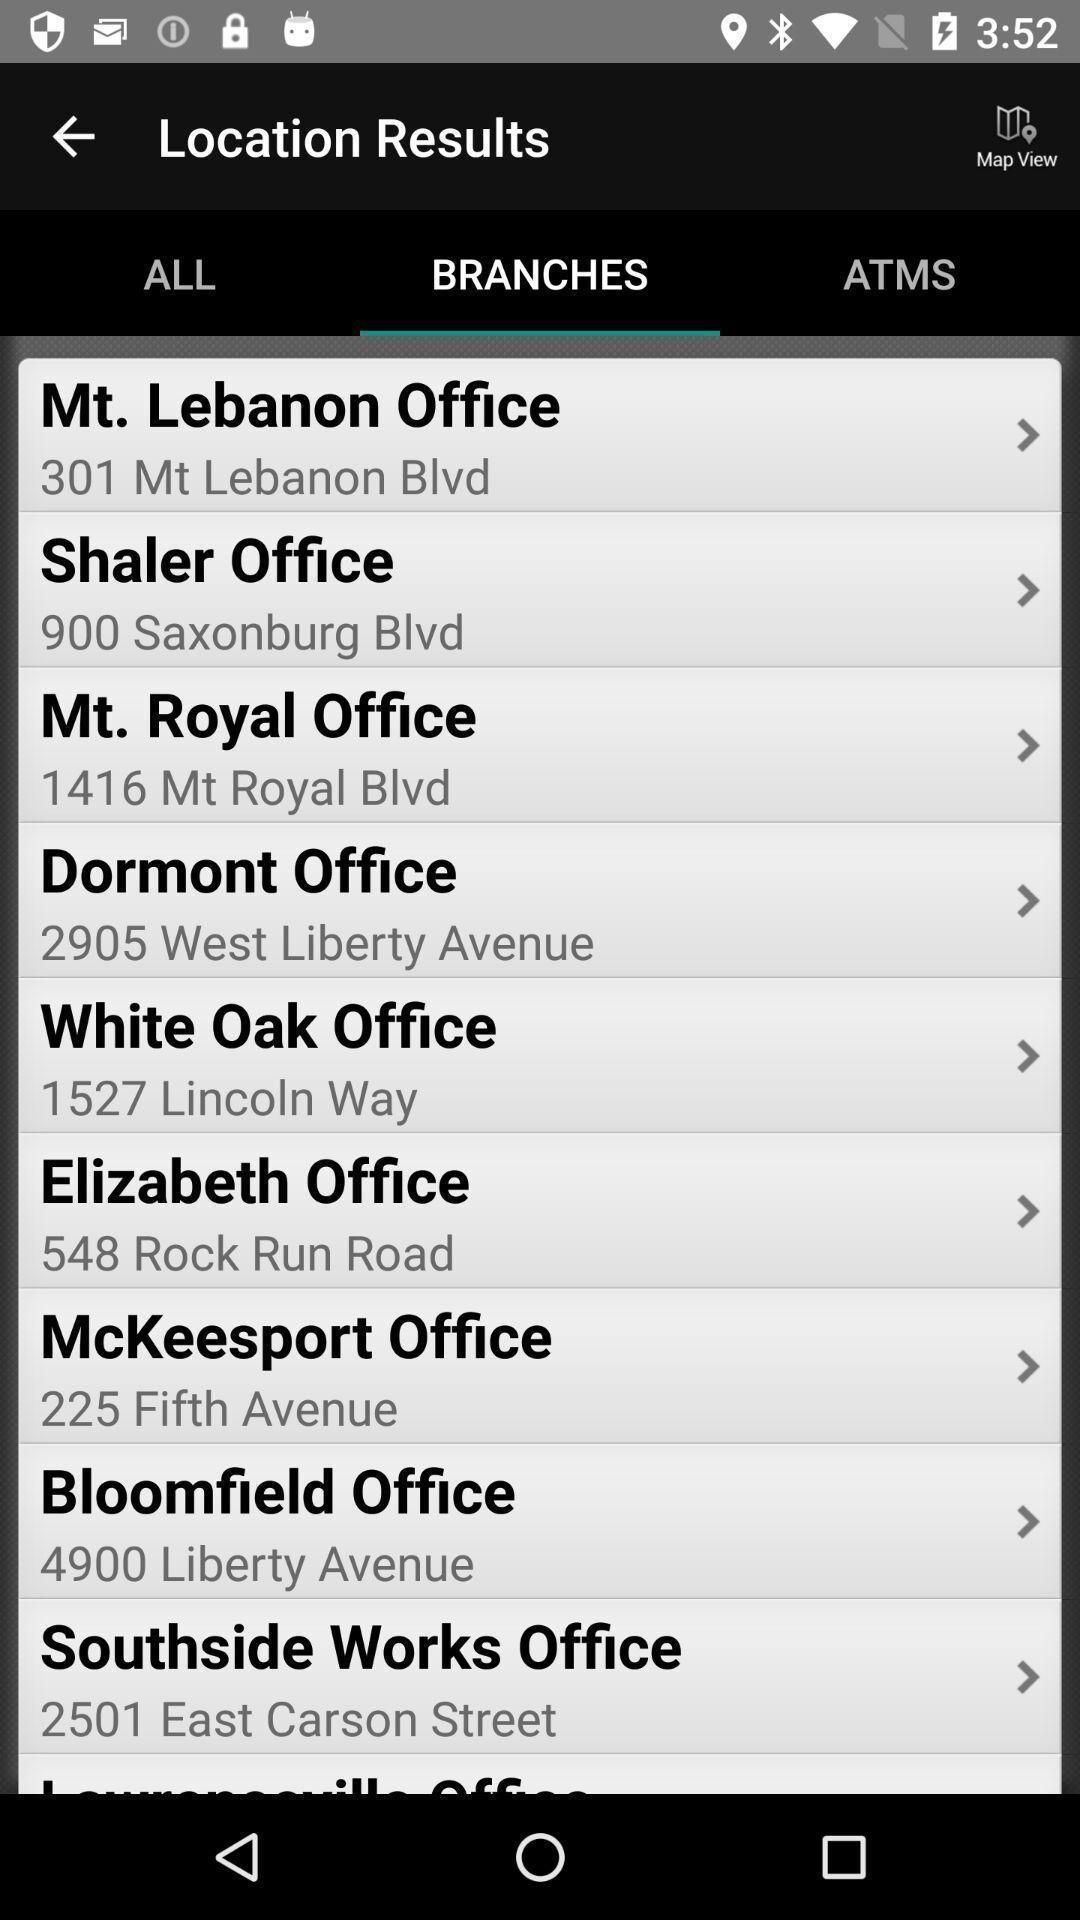What can you discern from this picture? Page displaying the list of branches in the location. 